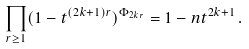Convert formula to latex. <formula><loc_0><loc_0><loc_500><loc_500>\prod _ { r \geq 1 } ( 1 - t ^ { ( 2 k + 1 ) r } ) ^ { \Phi _ { 2 k r } } = 1 - n t ^ { 2 k + 1 } \, .</formula> 